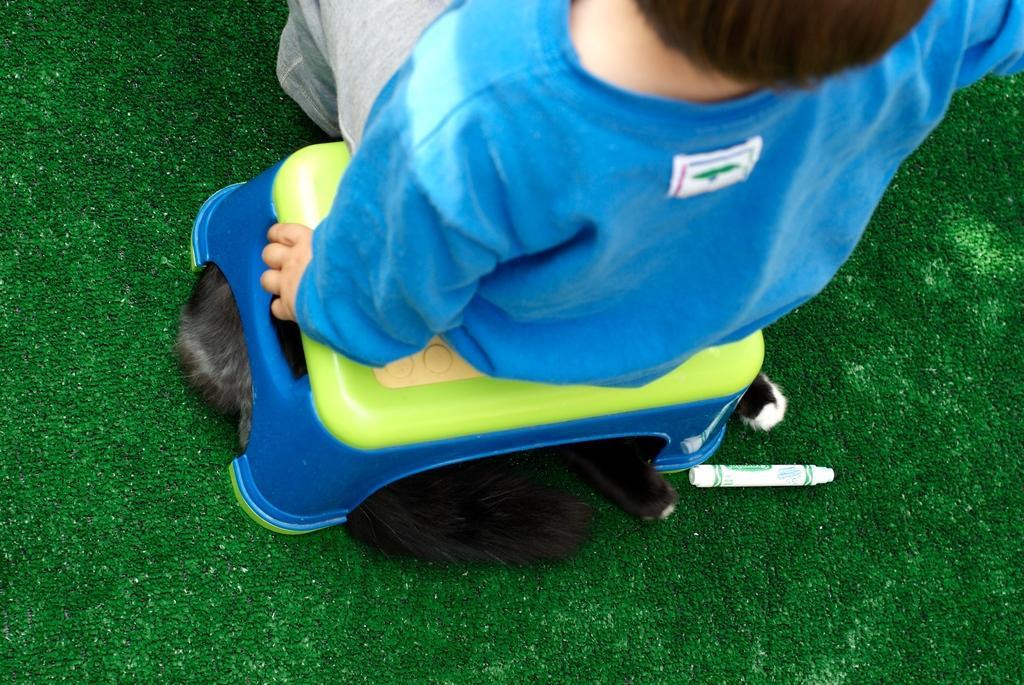Can you describe this image briefly? In this image a kid is sitting on a stool. A animal is lying under the stool. There is a marker on the carpet. Kid is wearing blue T-shirt. 